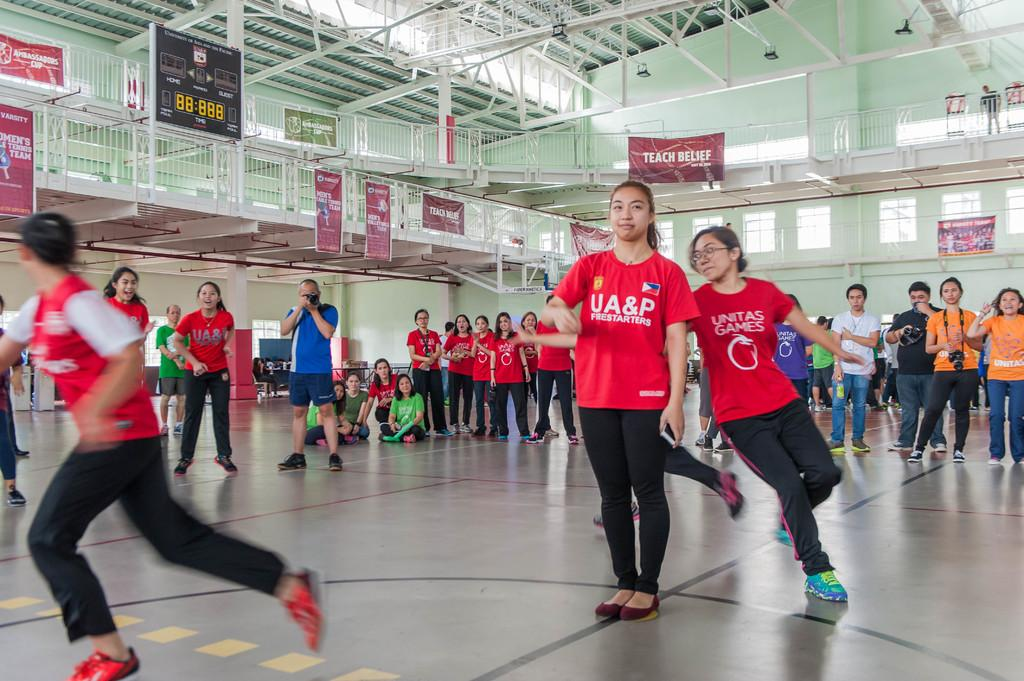How are the people in the image positioned? Some people are standing, while others are sitting. What type of structure can be seen in the image? There are iron grilles in the image. What additional decorative elements are present in the image? Banners are present in the image. What can be seen providing illumination in the image? Lights are visible in the image. What type of display is present in the image? There is a score display board in the image. What type of bed is visible in the image? There is no bed present in the image. What reward is being given to the people in the image? There is no reward being given in the image; it does not depict a situation where rewards are being distributed. 